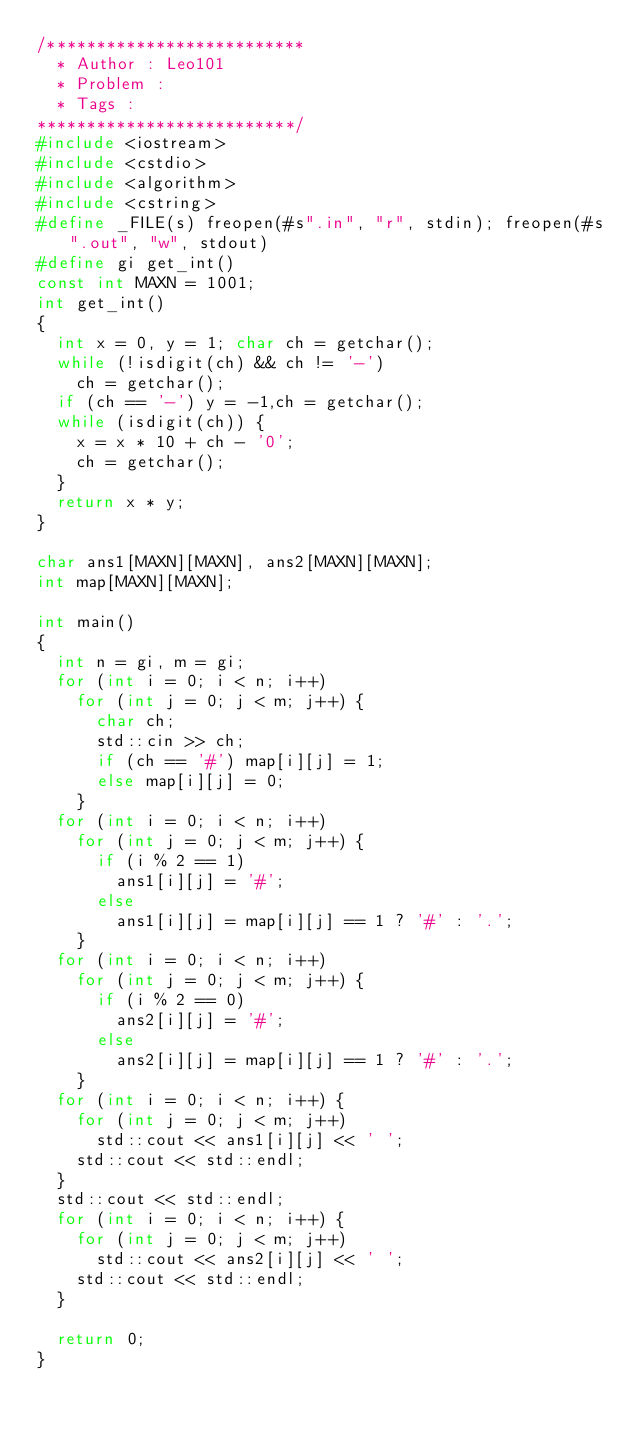Convert code to text. <code><loc_0><loc_0><loc_500><loc_500><_C++_>/**************************
  * Author : Leo101
  * Problem :
  * Tags :
**************************/
#include <iostream>
#include <cstdio>
#include <algorithm>
#include <cstring>
#define _FILE(s) freopen(#s".in", "r", stdin); freopen(#s".out", "w", stdout)
#define gi get_int()
const int MAXN = 1001;
int get_int() 
{
	int x = 0, y = 1; char ch = getchar();
	while (!isdigit(ch) && ch != '-')
		ch = getchar();
	if (ch == '-') y = -1,ch = getchar();
	while (isdigit(ch)) {
		x = x * 10 + ch - '0';
		ch = getchar();
	}
	return x * y;
}

char ans1[MAXN][MAXN], ans2[MAXN][MAXN];
int map[MAXN][MAXN];

int main() 
{
  int n = gi, m = gi;
  for (int i = 0; i < n; i++)
    for (int j = 0; j < m; j++) {
      char ch;
      std::cin >> ch;
      if (ch == '#') map[i][j] = 1;
      else map[i][j] = 0;
    }
  for (int i = 0; i < n; i++)
    for (int j = 0; j < m; j++) {
      if (i % 2 == 1)
        ans1[i][j] = '#';
      else 
        ans1[i][j] = map[i][j] == 1 ? '#' : '.';
    }
  for (int i = 0; i < n; i++) 
    for (int j = 0; j < m; j++) {
      if (i % 2 == 0)
        ans2[i][j] = '#';
      else 
        ans2[i][j] = map[i][j] == 1 ? '#' : '.';
    }
  for (int i = 0; i < n; i++) {
    for (int j = 0; j < m; j++)
      std::cout << ans1[i][j] << ' ';
    std::cout << std::endl;
  }
  std::cout << std::endl;
  for (int i = 0; i < n; i++) {
    for (int j = 0; j < m; j++)
      std::cout << ans2[i][j] << ' ';
    std::cout << std::endl;
  }

	return 0;
}
</code> 